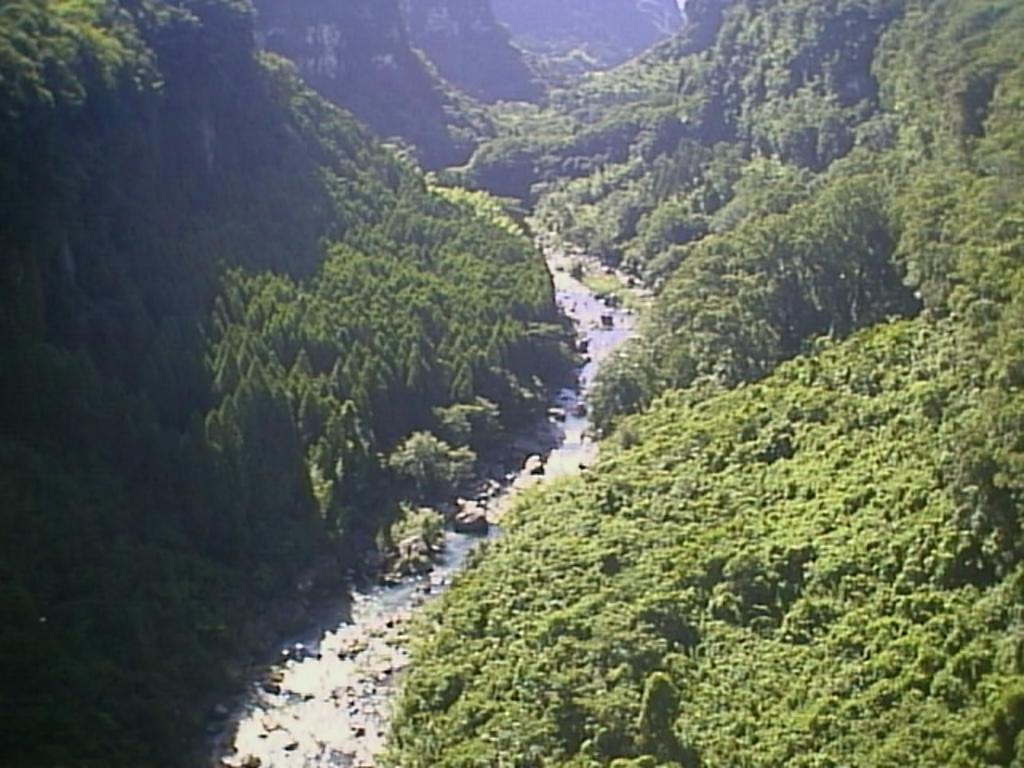What type of geographical feature is depicted in the image? There is a river valley in the image. What kind of vegetation can be seen in the image? Tall trees are present in the image. What other natural features are visible in the image? Mountains are visible in the image. How many tickets are needed to enter the lake in the image? There is no lake present in the image, so the question about tickets is not applicable. 